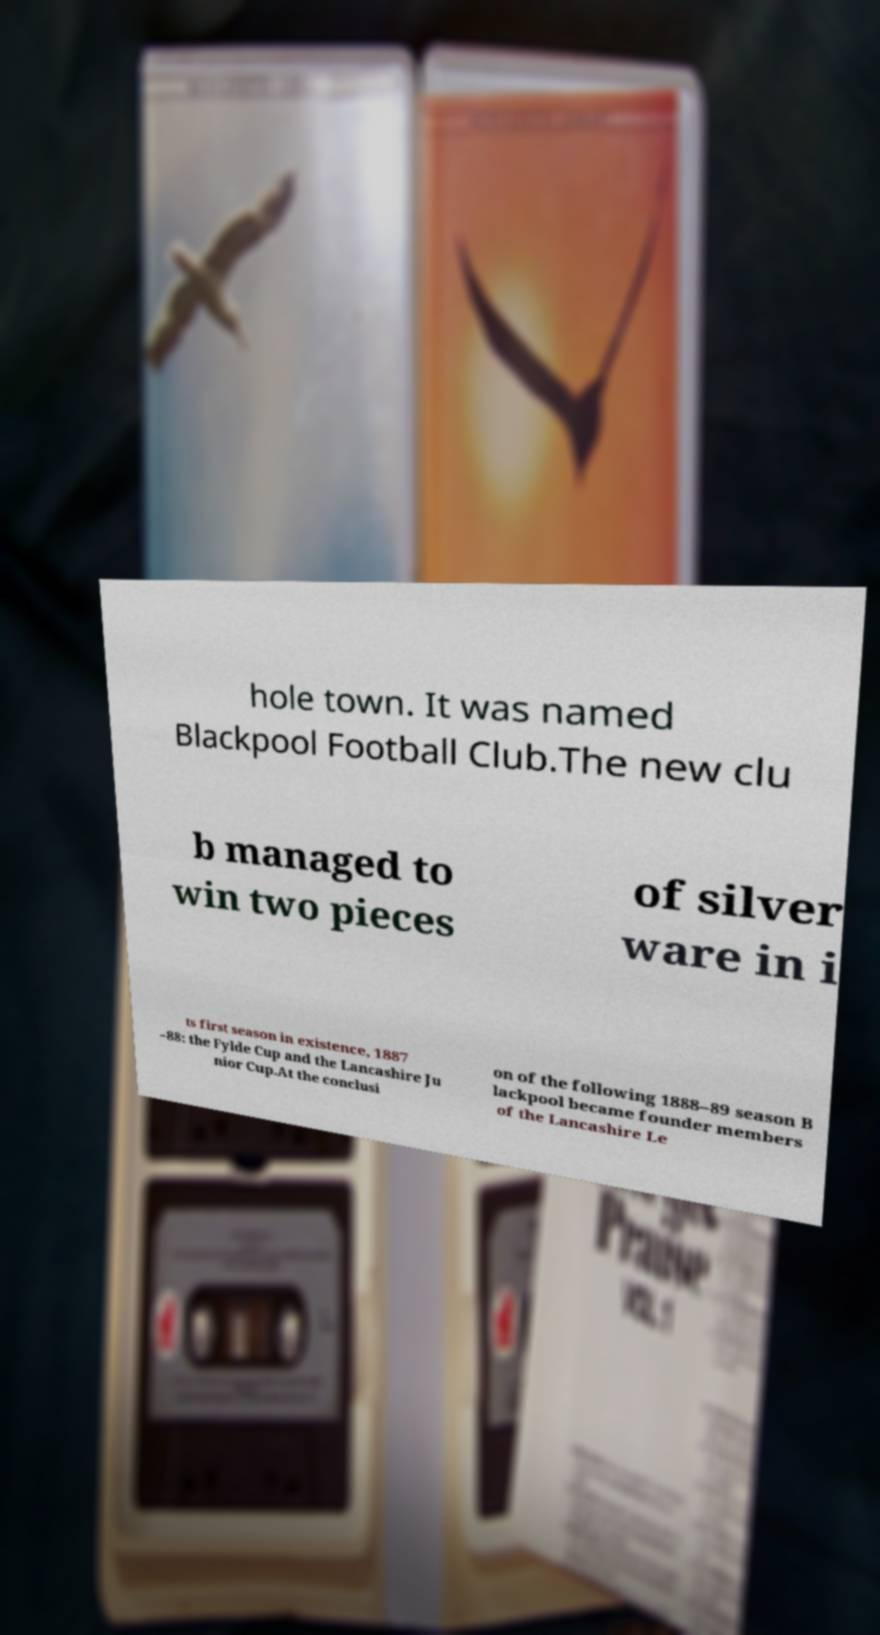Can you read and provide the text displayed in the image?This photo seems to have some interesting text. Can you extract and type it out for me? hole town. It was named Blackpool Football Club.The new clu b managed to win two pieces of silver ware in i ts first season in existence, 1887 –88: the Fylde Cup and the Lancashire Ju nior Cup.At the conclusi on of the following 1888–89 season B lackpool became founder members of the Lancashire Le 